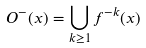<formula> <loc_0><loc_0><loc_500><loc_500>O ^ { - } ( x ) = \bigcup _ { k \geq 1 } f ^ { - k } ( x )</formula> 